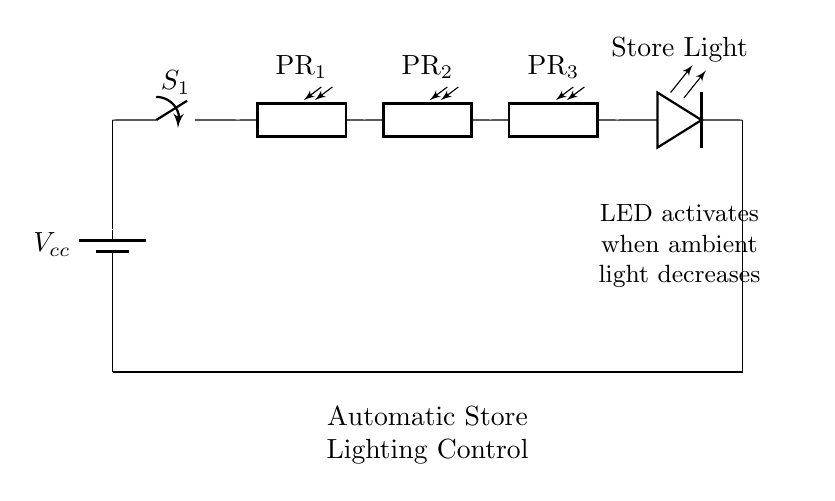What components are in this circuit? The circuit has a battery, a switch, three photoresistors, and an LED. These components can be seen clearly in the diagram as individual symbols.
Answer: battery, switch, photoresistors, LED What is the purpose of the photoresistors? The photoresistors detect ambient light levels, allowing the circuit to control the lighting based on the amount of light; when it decreases, the LED is activated.
Answer: Light detection How many photoresistors are used? There are three photoresistors in series in the circuit. This can be counted directly from the diagram.
Answer: Three What is the function of the switch? The switch allows the circuit to be turned on or off, controlling the flow of current and thus the operation of the lighting system.
Answer: On/Off control How does the circuit know to turn on the LED? The LED turns on when the combined resistance of the photoresistors decreases due to low ambient light, completing the circuit for current flow. Each photoresistor's resistance varies with light exposure.
Answer: Low light condition What type of circuit is this? This is a series circuit since all components are connected end-to-end, so the same current flows through each component.
Answer: Series circuit 